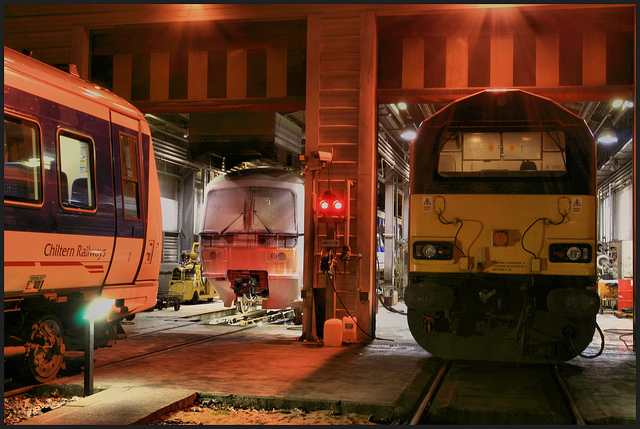Please identify all text content in this image. Chiltern 